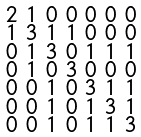<formula> <loc_0><loc_0><loc_500><loc_500>\begin{smallmatrix} 2 & 1 & 0 & 0 & 0 & 0 & 0 \\ 1 & 3 & 1 & 1 & 0 & 0 & 0 \\ 0 & 1 & 3 & 0 & 1 & 1 & 1 \\ 0 & 1 & 0 & 3 & 0 & 0 & 0 \\ 0 & 0 & 1 & 0 & 3 & 1 & 1 \\ 0 & 0 & 1 & 0 & 1 & 3 & 1 \\ 0 & 0 & 1 & 0 & 1 & 1 & 3 \end{smallmatrix}</formula> 